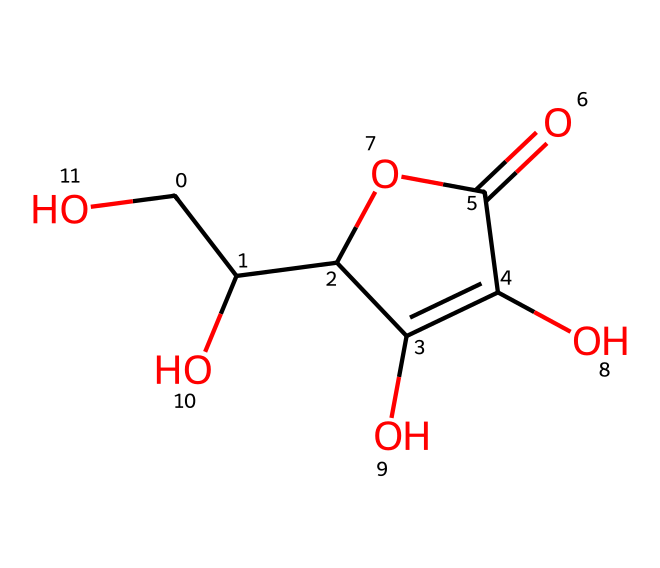What is the molecular formula of ascorbic acid? By analyzing the structure, we identify that ascorbic acid contains six carbon atoms, eight hydrogen atoms, and six oxygen atoms. Thus, the molecular formula is C6H8O6.
Answer: C6H8O6 How many hydroxyl (–OH) groups are present in ascorbic acid? The structure shows multiple –OH groups attached to the carbon atoms. By counting, we find there are four hydroxyl groups in total.
Answer: four What type of functional group is present at the end of the structure of ascorbic acid? Looking at the molecule, it concludes with a carboxylic acid group (-COOH), which is typical of compounds that can donate protons.
Answer: carboxylic acid What is the number of double bonds in ascorbic acid? Observing the structure, we see there are two double bonds present in the ring structure (C=C) and the carbonyl group (C=O), for a total of two.
Answer: two How does ascorbic acid contribute to human health? As a vital nutrient, it acts as an antioxidant in the body, helping to protect cells from damage and supporting the immune system.
Answer: antioxidant What is the structural arrangement of the chiral centers in ascorbic acid? Ascorbic acid has two chiral centers located at the C2 and C3 positions. This arrangement contributes to its stereochemistry and biological function.
Answer: two 